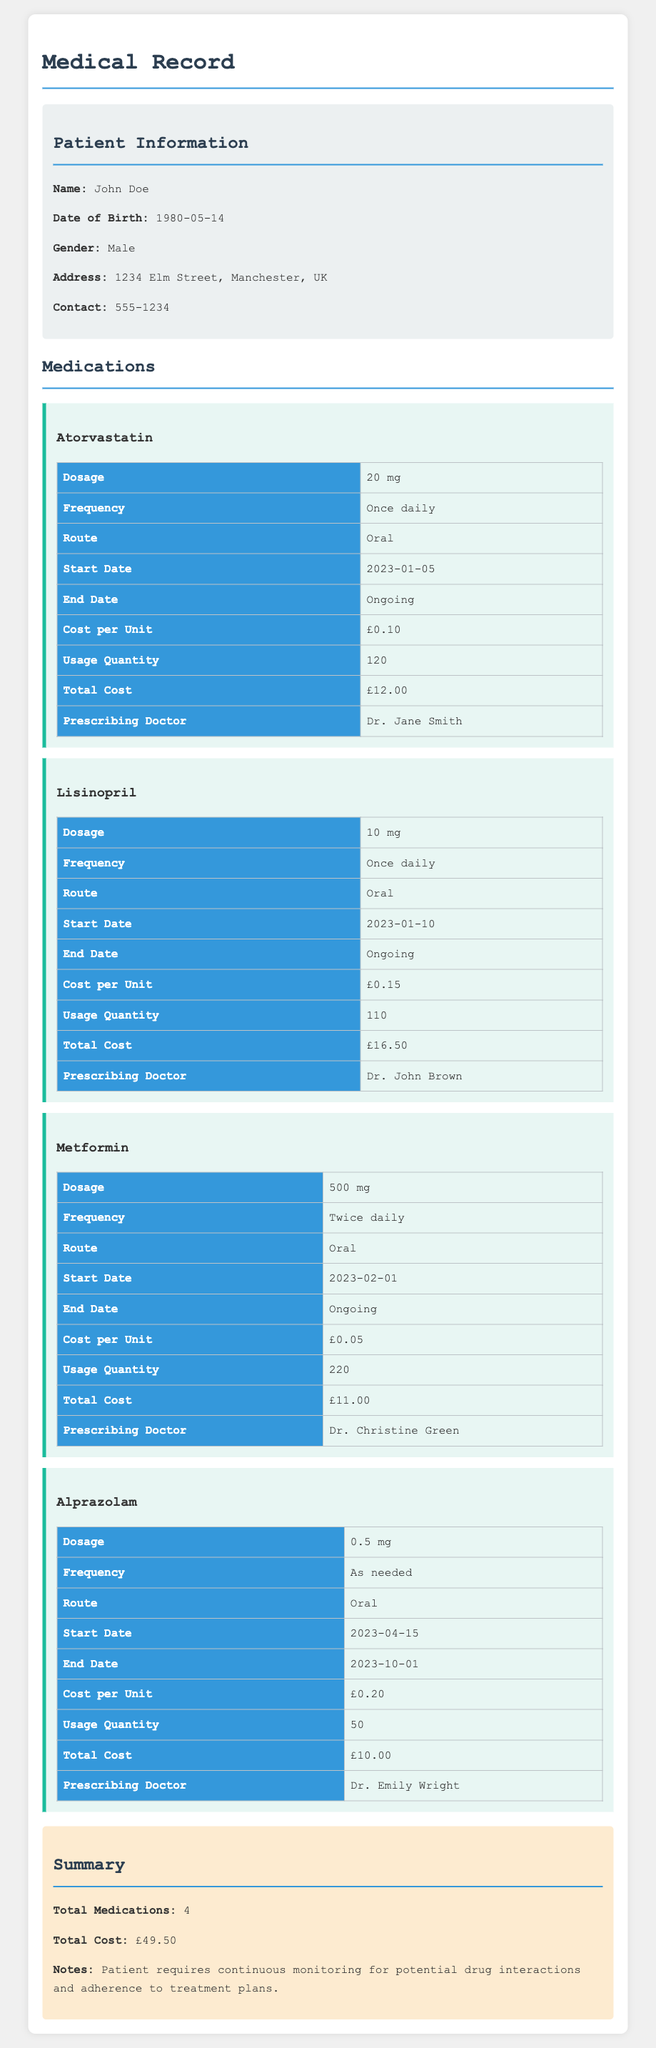What is the name of the patient? The name of the patient is listed in the patient information section.
Answer: John Doe What is the cost per unit of Atorvastatin? The cost per unit can be found in the medication section for Atorvastatin.
Answer: £0.10 How many medications are listed in total? The total number of medications is summarized at the end of the document.
Answer: 4 What is the total cost of all medications? The total cost is explicitly stated in the summary section.
Answer: £49.50 Who prescribed the medication Metformin? The name of the prescribing doctor for Metformin is in the medication's details.
Answer: Dr. Christine Green What is the dosage of Lisinopril? The dosage for Lisinopril is provided in its specific medication section.
Answer: 10 mg When did the patient start taking Alprazolam? The start date for Alprazolam is indicated in the medication details.
Answer: 2023-04-15 What is the frequency of Metformin usage? The frequency of Metformin is noted in the corresponding medication details.
Answer: Twice daily What is the end date for Alprazolam? The end date for Alprazolam is specified in its medication section.
Answer: 2023-10-01 